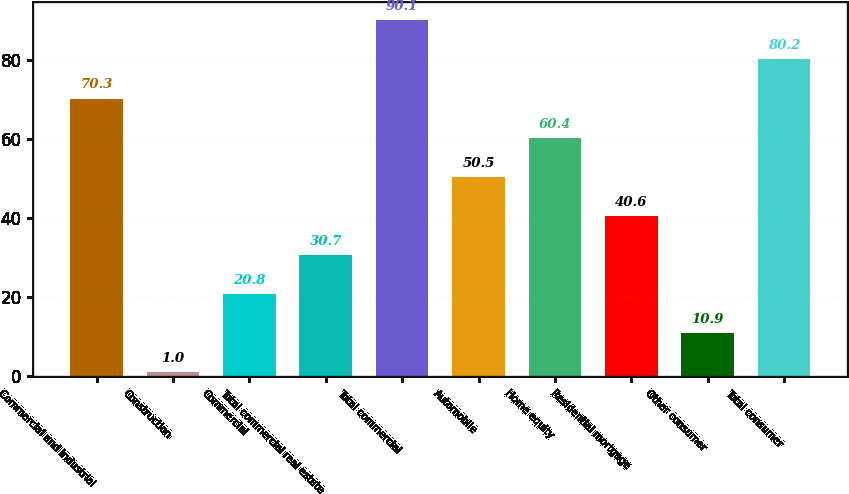Convert chart. <chart><loc_0><loc_0><loc_500><loc_500><bar_chart><fcel>Commercial and industrial<fcel>Construction<fcel>Commercial<fcel>Total commercial real estate<fcel>Total commercial<fcel>Automobile<fcel>Home equity<fcel>Residential mortgage<fcel>Other consumer<fcel>Total consumer<nl><fcel>70.3<fcel>1<fcel>20.8<fcel>30.7<fcel>90.1<fcel>50.5<fcel>60.4<fcel>40.6<fcel>10.9<fcel>80.2<nl></chart> 